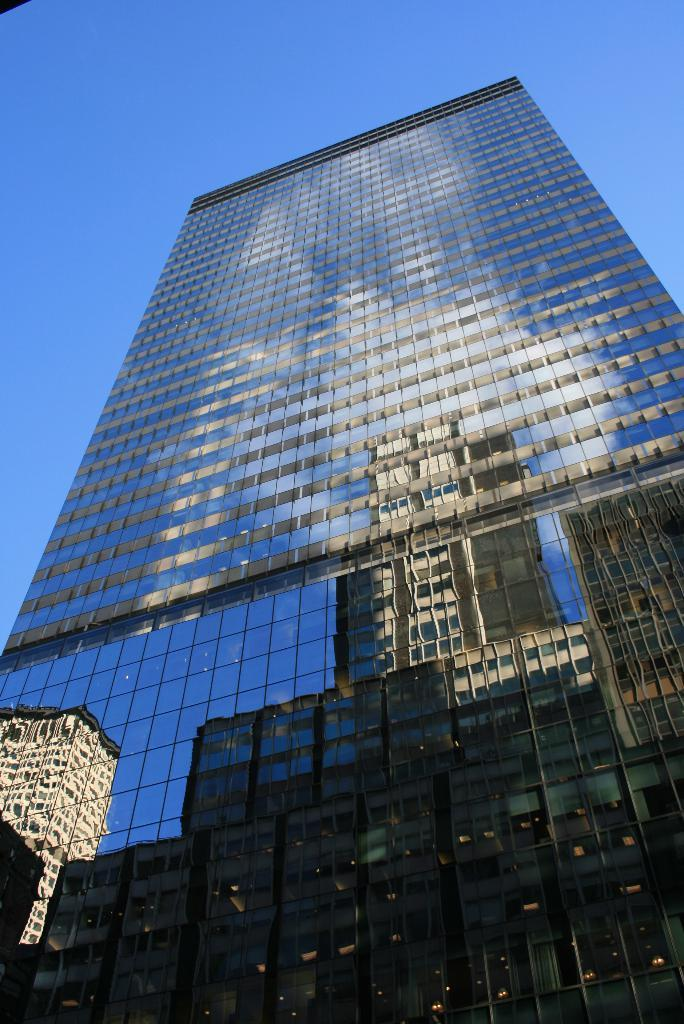What is the main structure in the picture? There is a building in the picture. What can be seen at the top of the picture? The sky is visible at the top of the picture. What objects are on the building? There are glasses on the building. What is reflected in these glasses? There is a reflection of another building on these glasses. What type of clam can be seen holding a wrench in the image? There is no clam or wrench present in the image. Can you describe the face of the person reflected in the glasses? The image does not show a person's face; it only shows a reflection of another building on the glasses. 